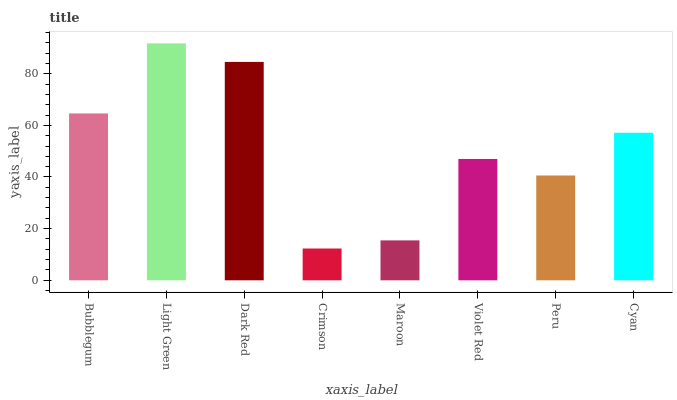Is Crimson the minimum?
Answer yes or no. Yes. Is Light Green the maximum?
Answer yes or no. Yes. Is Dark Red the minimum?
Answer yes or no. No. Is Dark Red the maximum?
Answer yes or no. No. Is Light Green greater than Dark Red?
Answer yes or no. Yes. Is Dark Red less than Light Green?
Answer yes or no. Yes. Is Dark Red greater than Light Green?
Answer yes or no. No. Is Light Green less than Dark Red?
Answer yes or no. No. Is Cyan the high median?
Answer yes or no. Yes. Is Violet Red the low median?
Answer yes or no. Yes. Is Bubblegum the high median?
Answer yes or no. No. Is Bubblegum the low median?
Answer yes or no. No. 